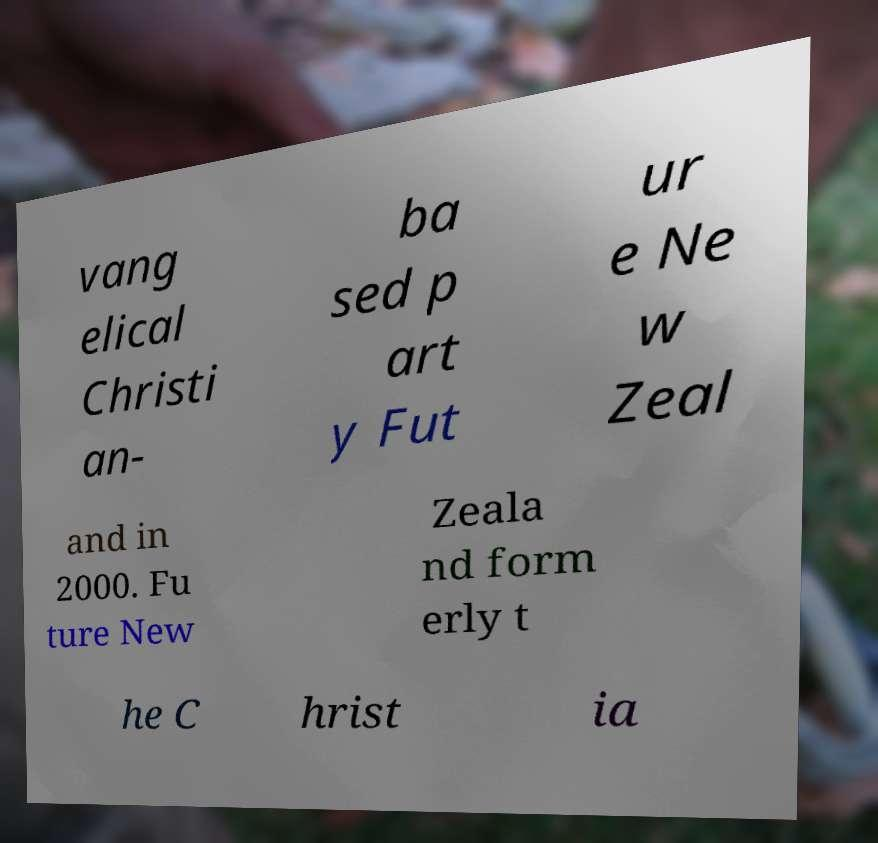I need the written content from this picture converted into text. Can you do that? vang elical Christi an- ba sed p art y Fut ur e Ne w Zeal and in 2000. Fu ture New Zeala nd form erly t he C hrist ia 